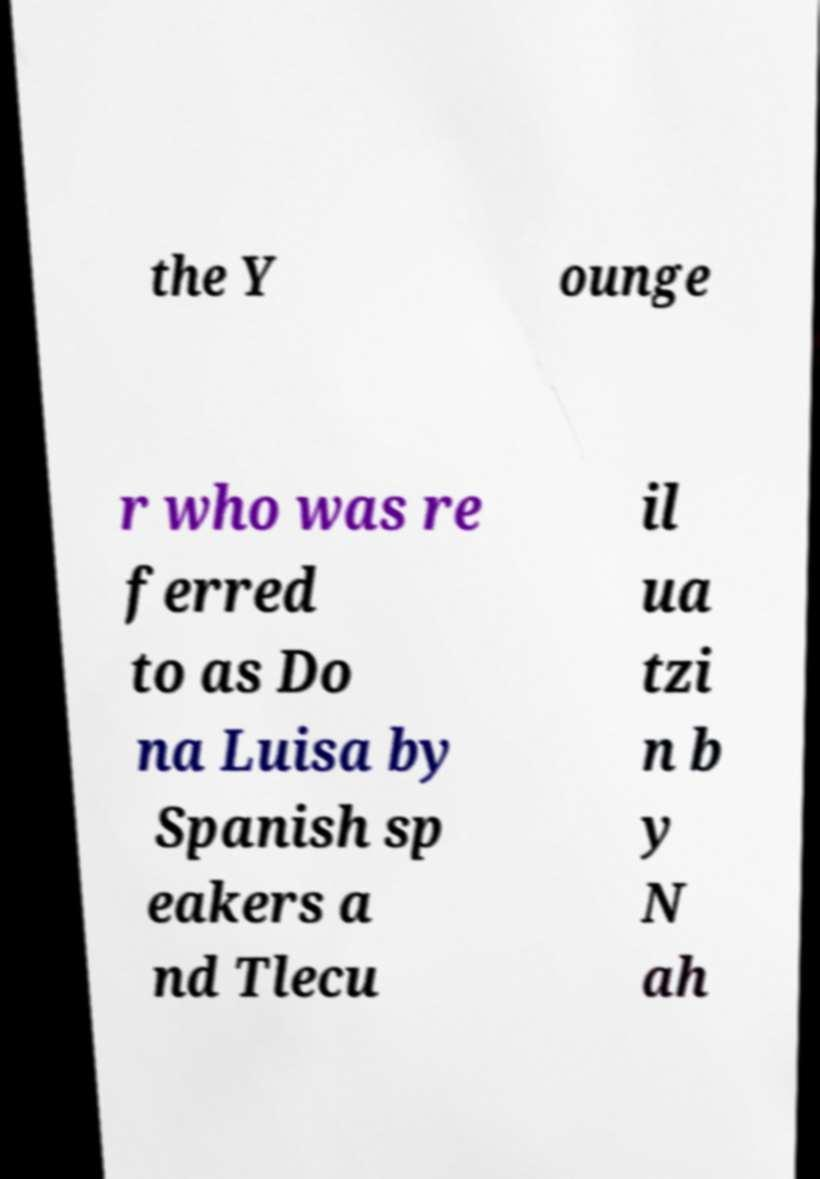Please identify and transcribe the text found in this image. the Y ounge r who was re ferred to as Do na Luisa by Spanish sp eakers a nd Tlecu il ua tzi n b y N ah 